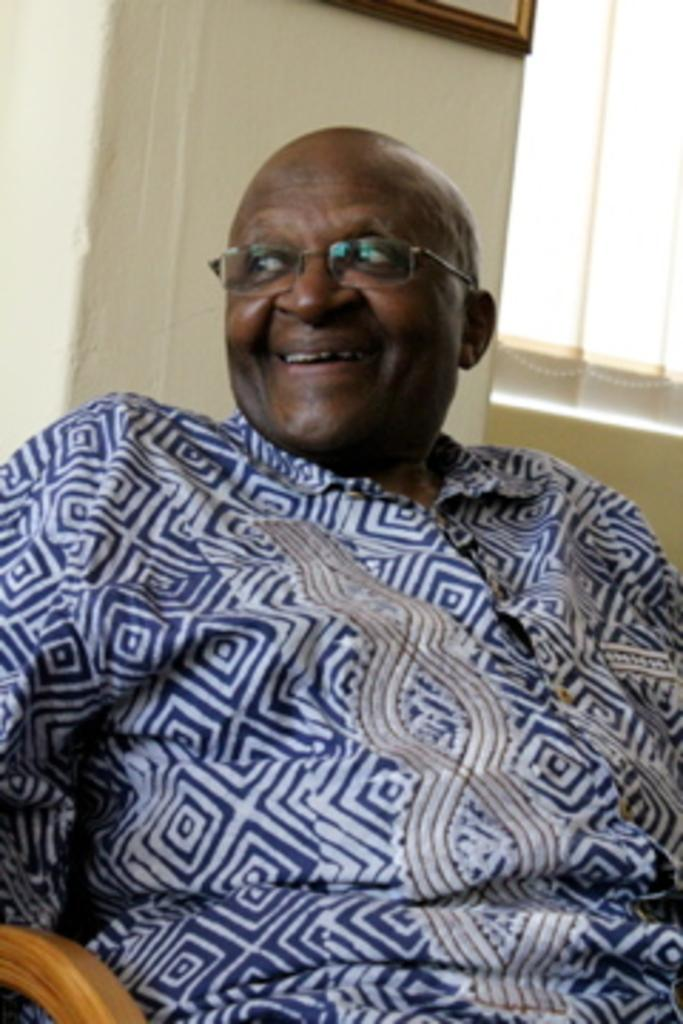Who is present in the image? There is a man in the image. What is the man doing in the image? The man is seated on a chair. What expression does the man have in the image? The man is smiling. What accessory is the man wearing in the image? The man is wearing spectacles. What can be seen on the wall in the image? There is a frame on the wall in the image. What type of window treatment is visible in the image? There are blinds on the window in the image. What type of cream can be seen in the man's hand in the image? There is no cream visible in the man's hand in the image. What type of eggnog is being served in the image? There is no eggnog present in the image. What color is the banana on the table in the image? There is no banana present in the image. 